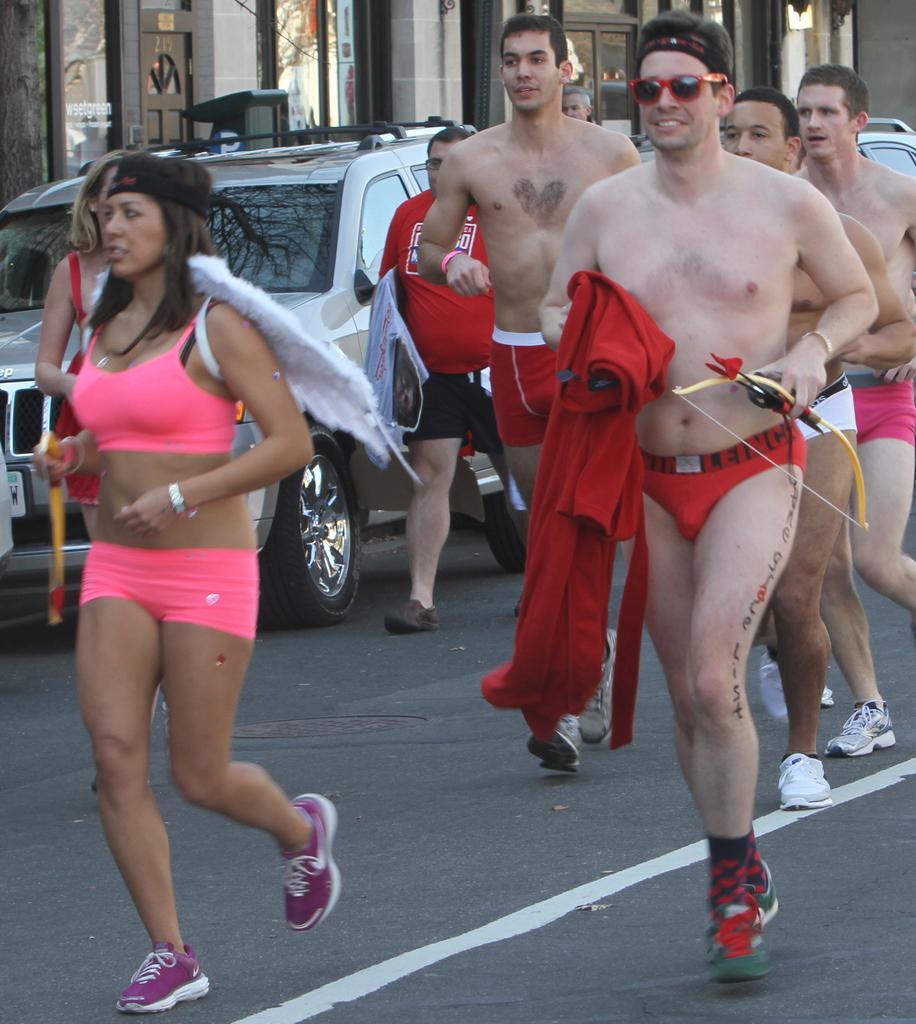Please provide a concise description of this image. In this image there are group of men who are running on the road by wearing the red colour underwear and holding the bow and arrow with there hands. In the background there are cars. On the left side there is a woman who is running on the road. In the background there is a building with the glass windows. 